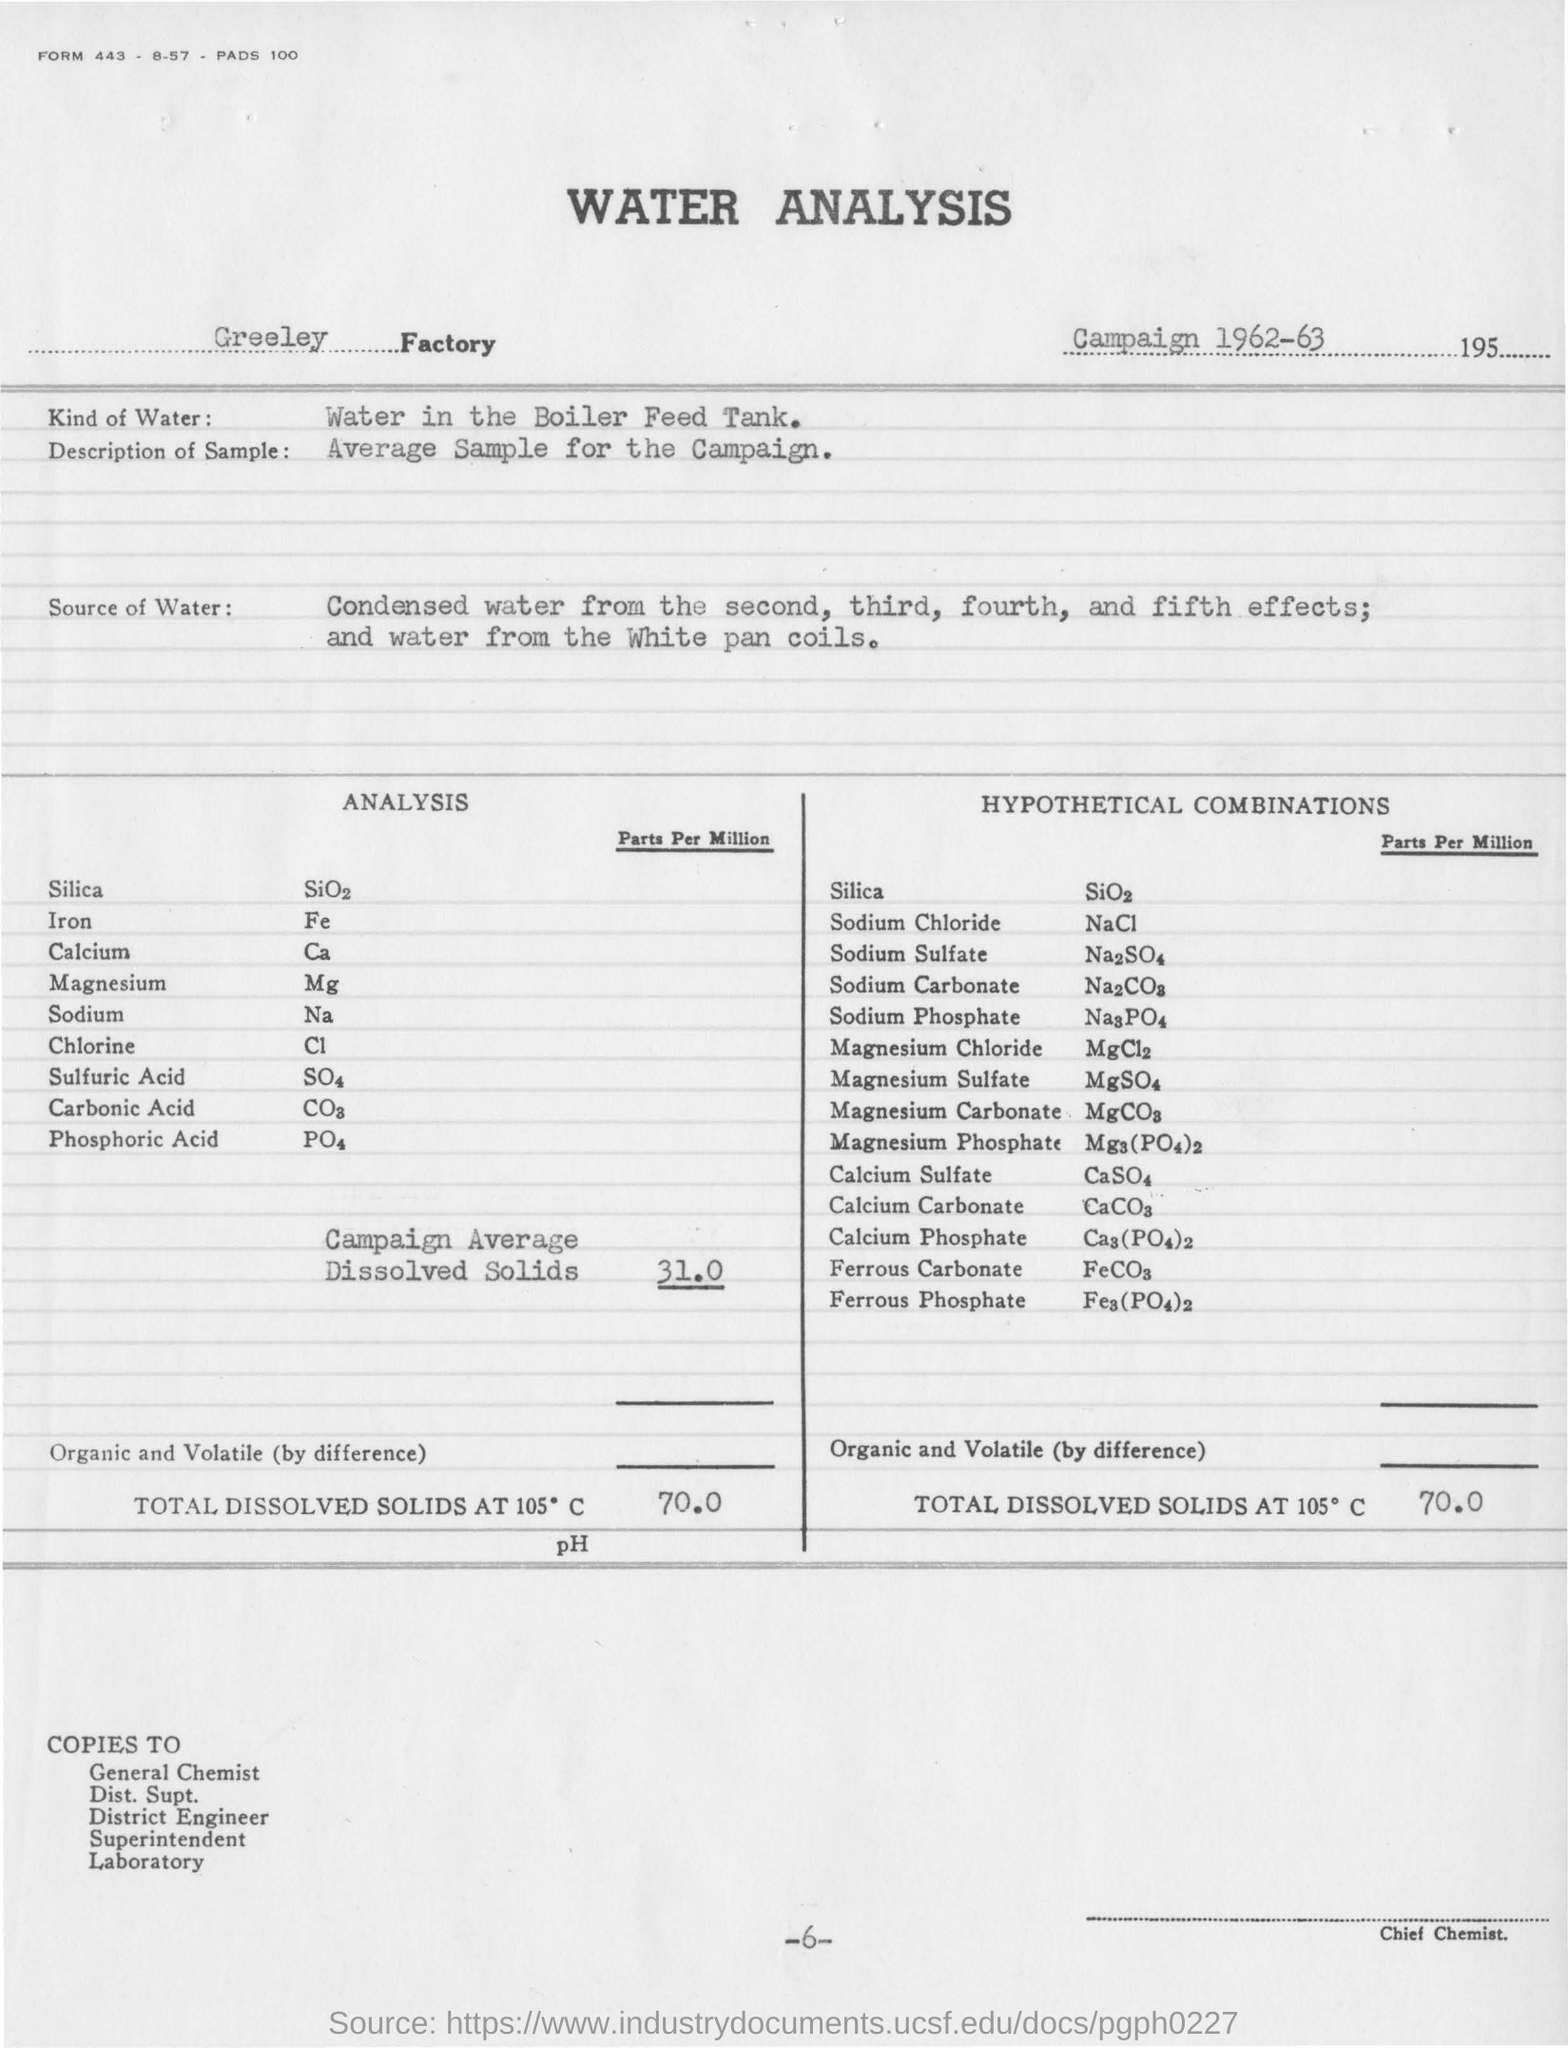Highlight a few significant elements in this photo. The analysis is being conducted at the Greeley Factory. The page number mentioned in this document is -6- and 6.. The document mentions water analysis. The average dissolved solids in Campaign is 31.0 parts per million. The water used for analysis is the water in the boiler feed tank. 